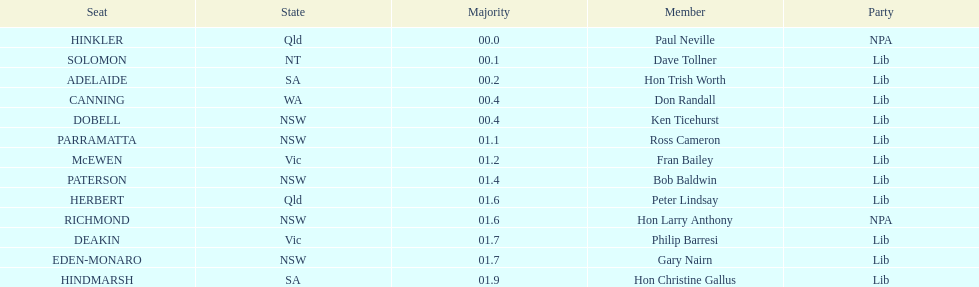How many states were accounted for in the seats? 6. 